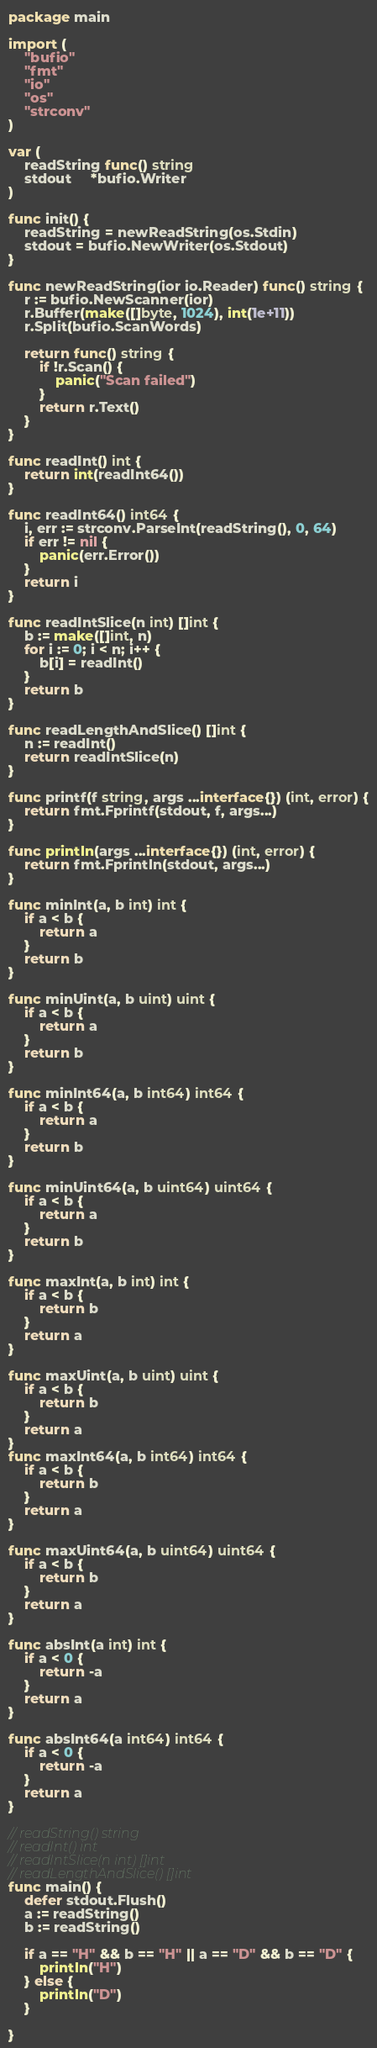Convert code to text. <code><loc_0><loc_0><loc_500><loc_500><_Go_>package main

import (
	"bufio"
	"fmt"
	"io"
	"os"
	"strconv"
)

var (
	readString func() string
	stdout     *bufio.Writer
)

func init() {
	readString = newReadString(os.Stdin)
	stdout = bufio.NewWriter(os.Stdout)
}

func newReadString(ior io.Reader) func() string {
	r := bufio.NewScanner(ior)
	r.Buffer(make([]byte, 1024), int(1e+11))
	r.Split(bufio.ScanWords)

	return func() string {
		if !r.Scan() {
			panic("Scan failed")
		}
		return r.Text()
	}
}

func readInt() int {
	return int(readInt64())
}

func readInt64() int64 {
	i, err := strconv.ParseInt(readString(), 0, 64)
	if err != nil {
		panic(err.Error())
	}
	return i
}

func readIntSlice(n int) []int {
	b := make([]int, n)
	for i := 0; i < n; i++ {
		b[i] = readInt()
	}
	return b
}

func readLengthAndSlice() []int {
	n := readInt()
	return readIntSlice(n)
}

func printf(f string, args ...interface{}) (int, error) {
	return fmt.Fprintf(stdout, f, args...)
}

func println(args ...interface{}) (int, error) {
	return fmt.Fprintln(stdout, args...)
}

func minInt(a, b int) int {
	if a < b {
		return a
	}
	return b
}

func minUint(a, b uint) uint {
	if a < b {
		return a
	}
	return b
}

func minInt64(a, b int64) int64 {
	if a < b {
		return a
	}
	return b
}

func minUint64(a, b uint64) uint64 {
	if a < b {
		return a
	}
	return b
}

func maxInt(a, b int) int {
	if a < b {
		return b
	}
	return a
}

func maxUint(a, b uint) uint {
	if a < b {
		return b
	}
	return a
}
func maxInt64(a, b int64) int64 {
	if a < b {
		return b
	}
	return a
}

func maxUint64(a, b uint64) uint64 {
	if a < b {
		return b
	}
	return a
}

func absInt(a int) int {
	if a < 0 {
		return -a
	}
	return a
}

func absInt64(a int64) int64 {
	if a < 0 {
		return -a
	}
	return a
}

// readString() string
// readInt() int
// readIntSlice(n int) []int
// readLengthAndSlice() []int
func main() {
	defer stdout.Flush()
	a := readString()
	b := readString()

	if a == "H" && b == "H" || a == "D" && b == "D" {
		println("H")
	} else {
		println("D")
	}

}
</code> 